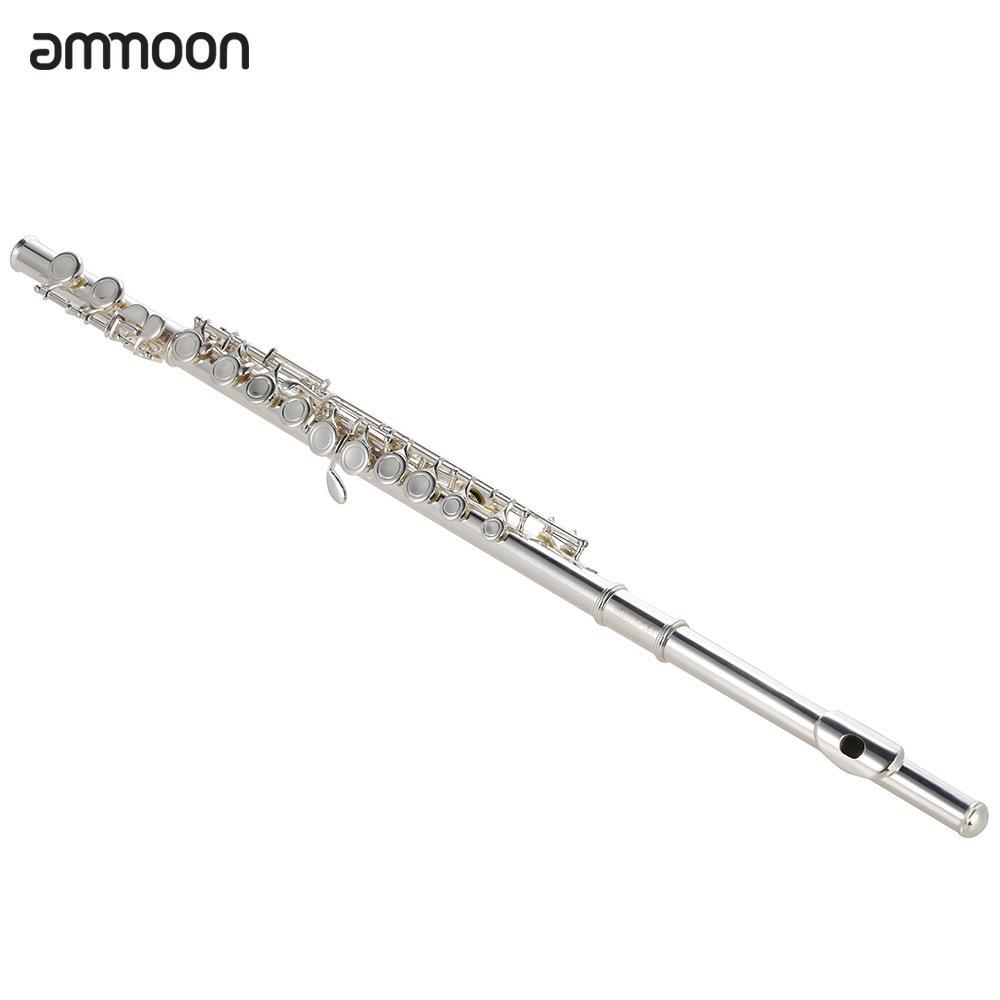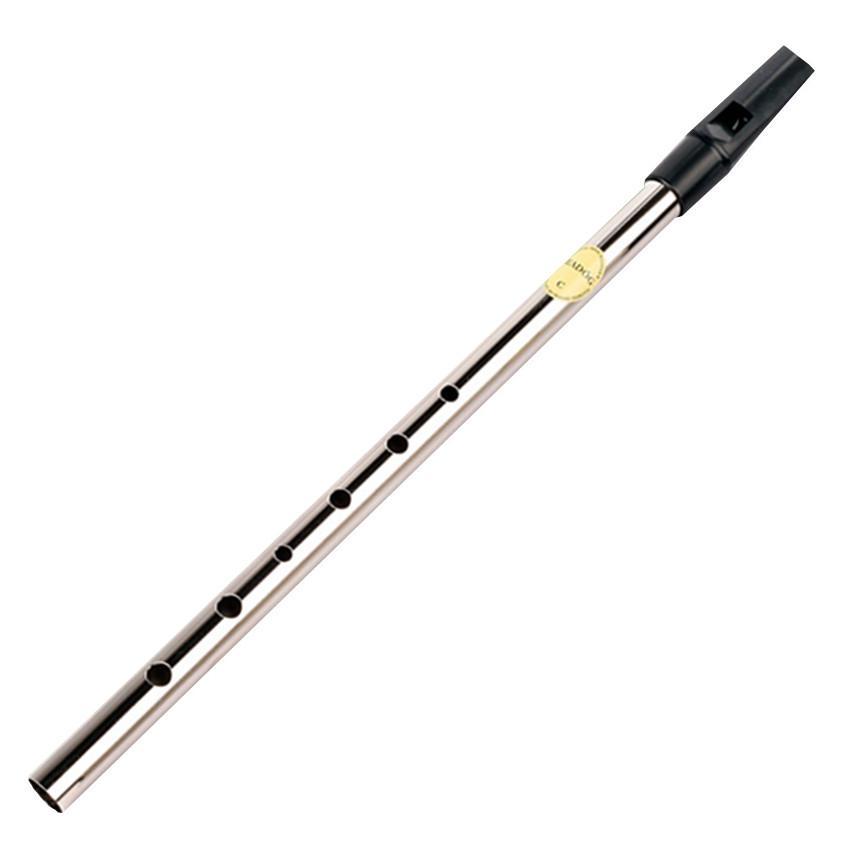The first image is the image on the left, the second image is the image on the right. Given the left and right images, does the statement "The flute-like instruments on the left and right are silver colored and displayed at opposite angles so they form a V shape." hold true? Answer yes or no. Yes. The first image is the image on the left, the second image is the image on the right. Analyze the images presented: Is the assertion "The left and right image contains the same number of silver flutes the are opposite facing." valid? Answer yes or no. Yes. 